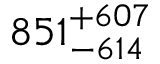<formula> <loc_0><loc_0><loc_500><loc_500>8 5 1 _ { - 6 1 4 } ^ { + 6 0 7 }</formula> 